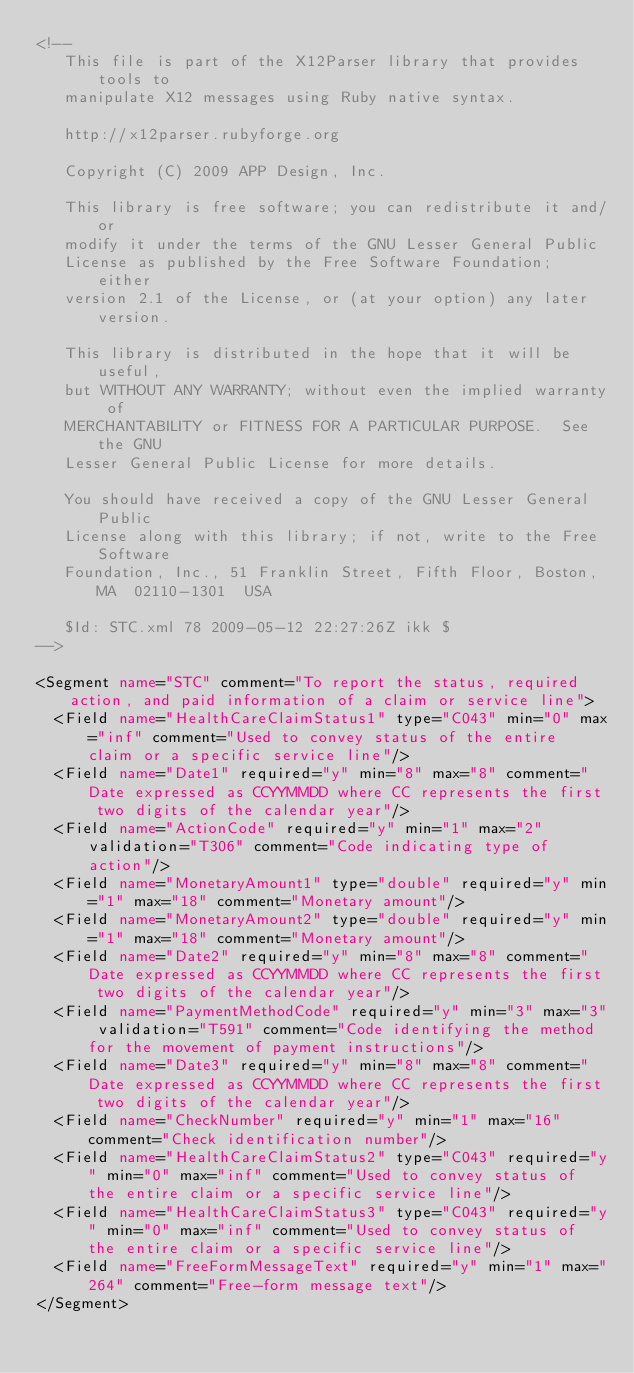<code> <loc_0><loc_0><loc_500><loc_500><_XML_><!--
   This file is part of the X12Parser library that provides tools to
   manipulate X12 messages using Ruby native syntax.

   http://x12parser.rubyforge.org 
   
   Copyright (C) 2009 APP Design, Inc.

   This library is free software; you can redistribute it and/or
   modify it under the terms of the GNU Lesser General Public
   License as published by the Free Software Foundation; either
   version 2.1 of the License, or (at your option) any later version.

   This library is distributed in the hope that it will be useful,
   but WITHOUT ANY WARRANTY; without even the implied warranty of
   MERCHANTABILITY or FITNESS FOR A PARTICULAR PURPOSE.  See the GNU
   Lesser General Public License for more details.

   You should have received a copy of the GNU Lesser General Public
   License along with this library; if not, write to the Free Software
   Foundation, Inc., 51 Franklin Street, Fifth Floor, Boston, MA  02110-1301  USA

   $Id: STC.xml 78 2009-05-12 22:27:26Z ikk $
-->

<Segment name="STC" comment="To report the status, required action, and paid information of a claim or service line">
  <Field name="HealthCareClaimStatus1" type="C043" min="0" max="inf" comment="Used to convey status of the entire claim or a specific service line"/>
  <Field name="Date1" required="y" min="8" max="8" comment="Date expressed as CCYYMMDD where CC represents the first two digits of the calendar year"/>
  <Field name="ActionCode" required="y" min="1" max="2" validation="T306" comment="Code indicating type of action"/>
  <Field name="MonetaryAmount1" type="double" required="y" min="1" max="18" comment="Monetary amount"/>
  <Field name="MonetaryAmount2" type="double" required="y" min="1" max="18" comment="Monetary amount"/>
  <Field name="Date2" required="y" min="8" max="8" comment="Date expressed as CCYYMMDD where CC represents the first two digits of the calendar year"/>
  <Field name="PaymentMethodCode" required="y" min="3" max="3" validation="T591" comment="Code identifying the method for the movement of payment instructions"/>
  <Field name="Date3" required="y" min="8" max="8" comment="Date expressed as CCYYMMDD where CC represents the first two digits of the calendar year"/>
  <Field name="CheckNumber" required="y" min="1" max="16" comment="Check identification number"/>
  <Field name="HealthCareClaimStatus2" type="C043" required="y" min="0" max="inf" comment="Used to convey status of the entire claim or a specific service line"/>
  <Field name="HealthCareClaimStatus3" type="C043" required="y" min="0" max="inf" comment="Used to convey status of the entire claim or a specific service line"/>
  <Field name="FreeFormMessageText" required="y" min="1" max="264" comment="Free-form message text"/>
</Segment>
</code> 